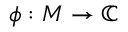Convert formula to latex. <formula><loc_0><loc_0><loc_500><loc_500>\phi \colon M \to \mathbb { C }</formula> 